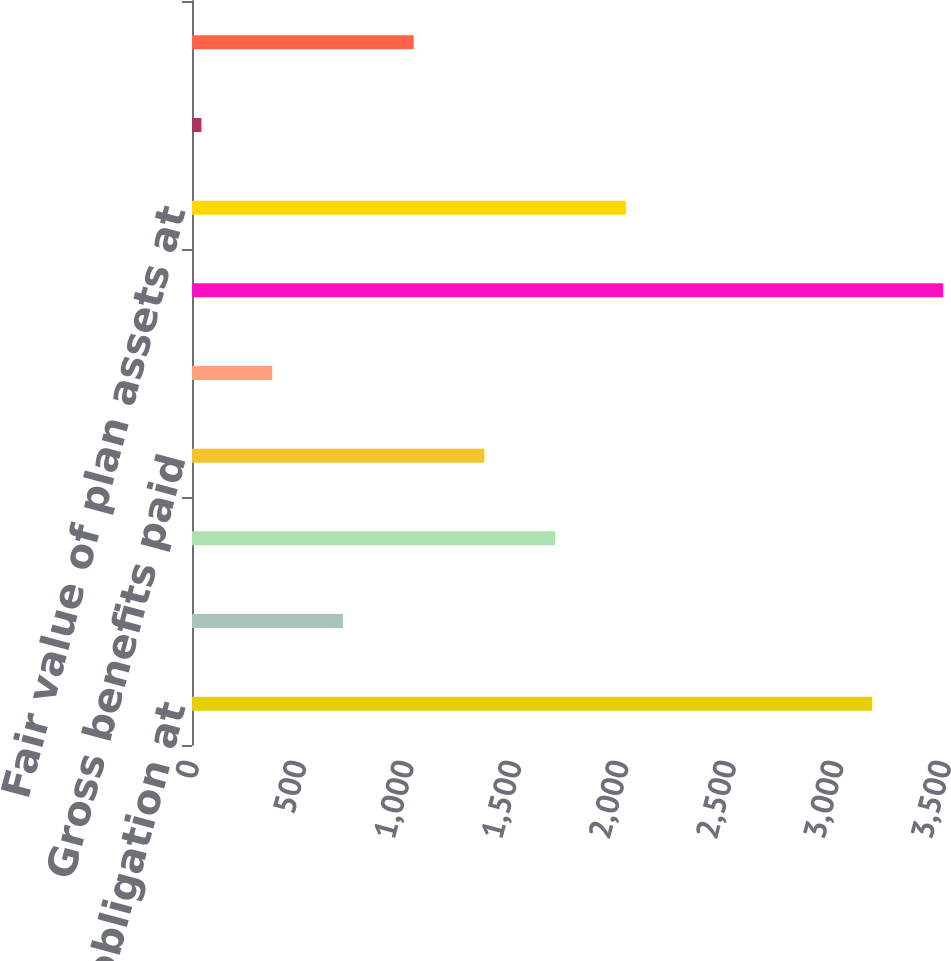<chart> <loc_0><loc_0><loc_500><loc_500><bar_chart><fcel>Net benefit obligation at<fcel>Service cost<fcel>Interest cost<fcel>Gross benefits paid<fcel>Actuarial (gain)/loss<fcel>Net benefit obligation at end<fcel>Fair value of plan assets at<fcel>Actual return on plan assets<fcel>Employer contributions<nl><fcel>3166<fcel>702.4<fcel>1690<fcel>1360.8<fcel>373.2<fcel>3495.2<fcel>2019.2<fcel>44<fcel>1031.6<nl></chart> 